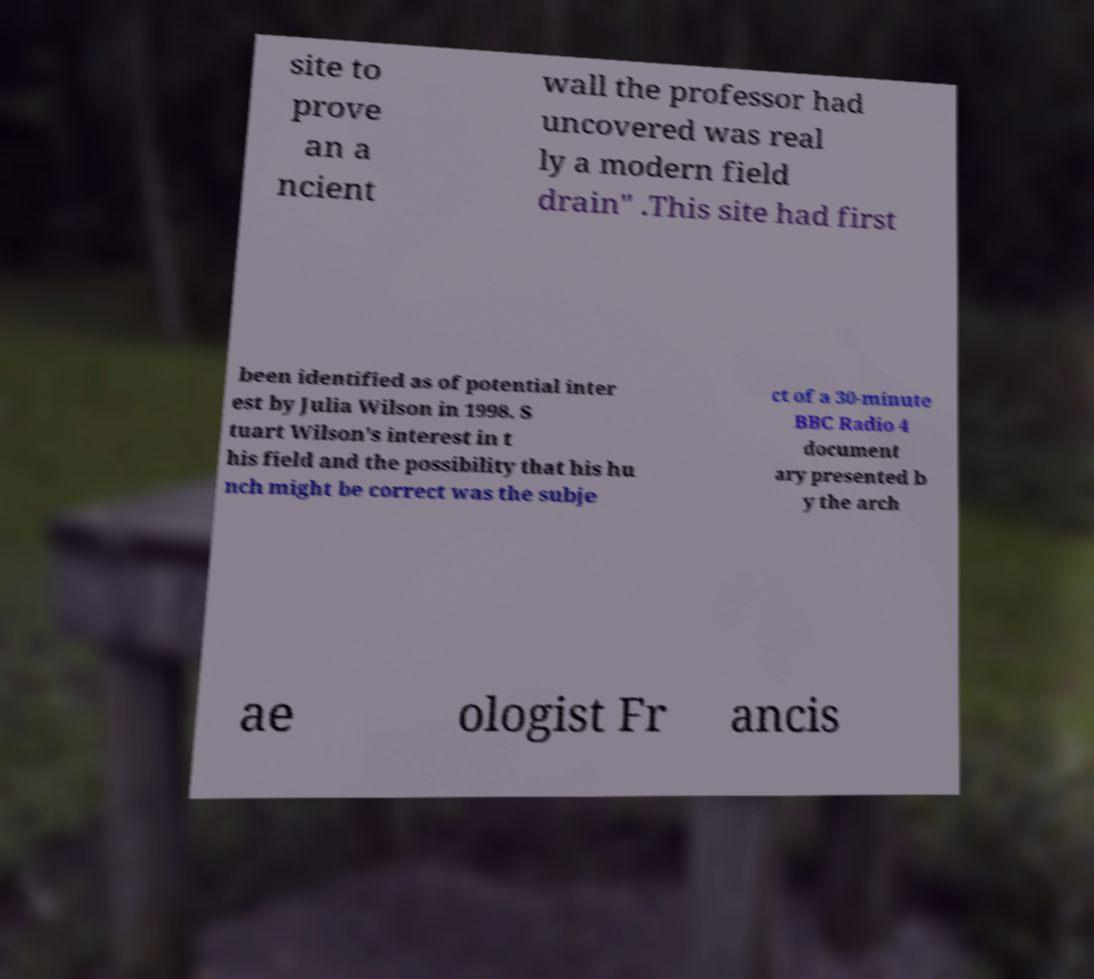Could you assist in decoding the text presented in this image and type it out clearly? site to prove an a ncient wall the professor had uncovered was real ly a modern field drain" .This site had first been identified as of potential inter est by Julia Wilson in 1998. S tuart Wilson's interest in t his field and the possibility that his hu nch might be correct was the subje ct of a 30-minute BBC Radio 4 document ary presented b y the arch ae ologist Fr ancis 